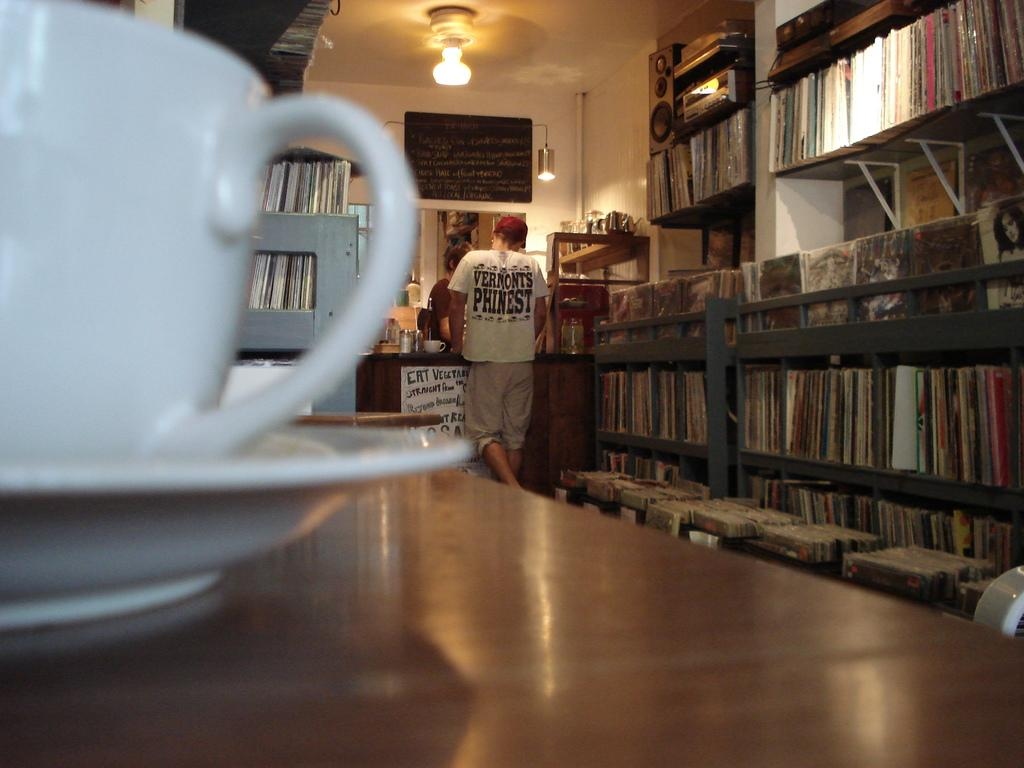<image>
Describe the image concisely. A white coffee cup in the foreground with a man in the background wearing a shirt reading Vermont's Phinest. 